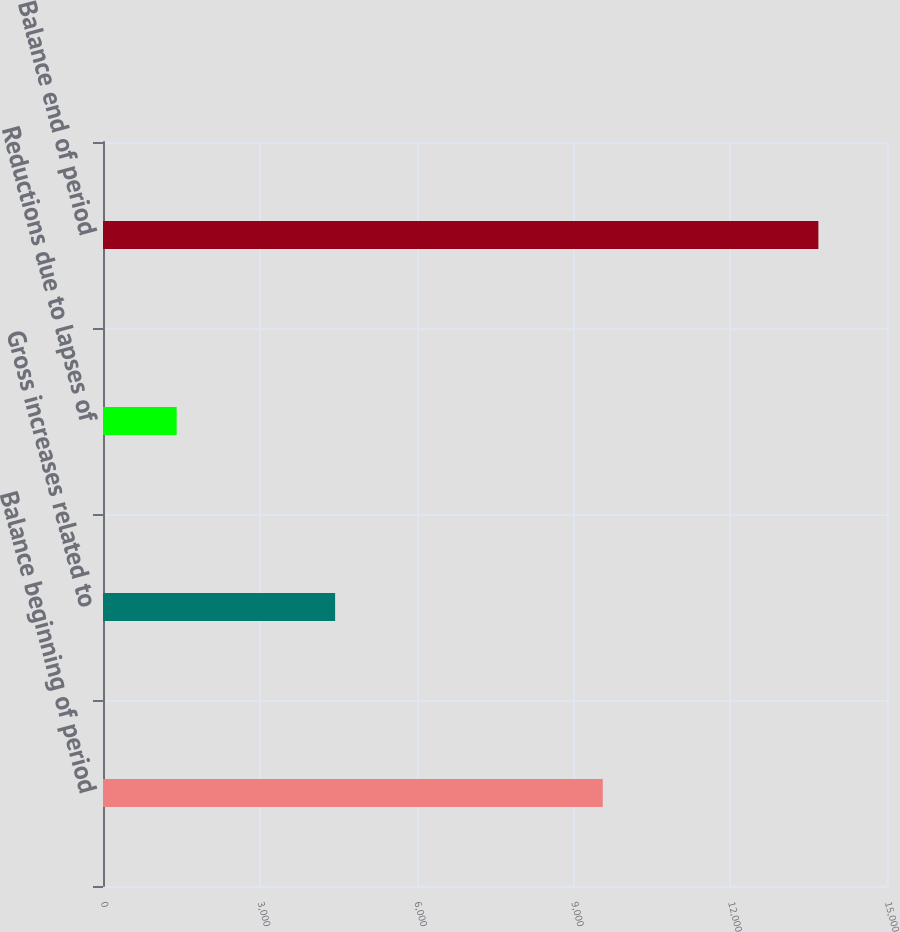Convert chart. <chart><loc_0><loc_0><loc_500><loc_500><bar_chart><fcel>Balance beginning of period<fcel>Gross increases related to<fcel>Reductions due to lapses of<fcel>Balance end of period<nl><fcel>9562<fcel>4441<fcel>1410<fcel>13687<nl></chart> 